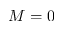Convert formula to latex. <formula><loc_0><loc_0><loc_500><loc_500>M = 0</formula> 